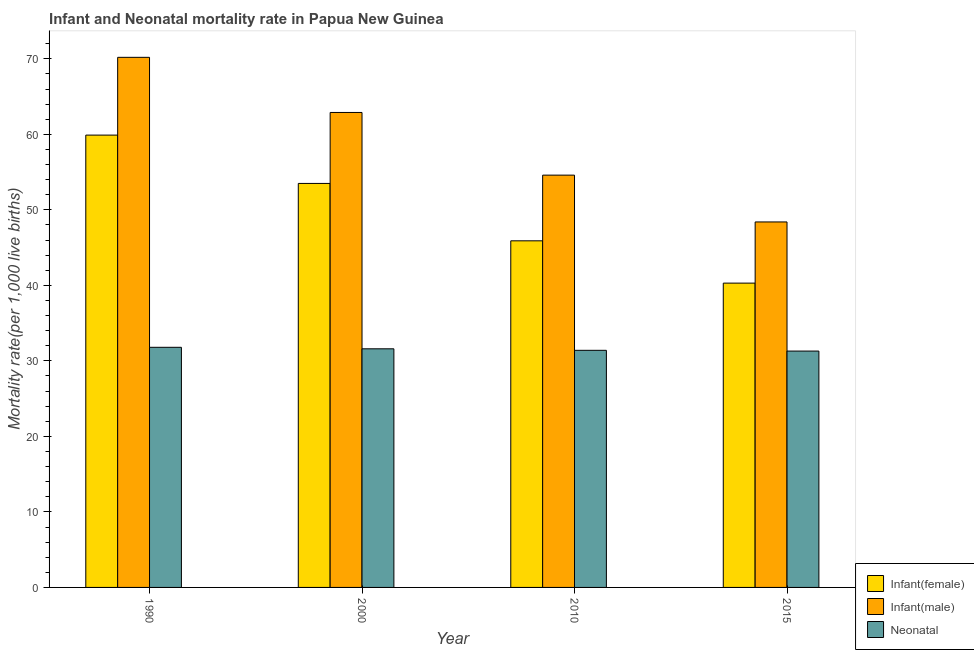How many groups of bars are there?
Your response must be concise. 4. Are the number of bars per tick equal to the number of legend labels?
Keep it short and to the point. Yes. How many bars are there on the 1st tick from the right?
Ensure brevity in your answer.  3. What is the label of the 1st group of bars from the left?
Provide a short and direct response. 1990. What is the infant mortality rate(female) in 1990?
Make the answer very short. 59.9. Across all years, what is the maximum infant mortality rate(female)?
Your response must be concise. 59.9. Across all years, what is the minimum neonatal mortality rate?
Your answer should be compact. 31.3. In which year was the neonatal mortality rate minimum?
Give a very brief answer. 2015. What is the total infant mortality rate(male) in the graph?
Give a very brief answer. 236.1. What is the difference between the infant mortality rate(male) in 2010 and that in 2015?
Your answer should be very brief. 6.2. What is the difference between the infant mortality rate(male) in 2000 and the infant mortality rate(female) in 2010?
Your answer should be compact. 8.3. What is the average neonatal mortality rate per year?
Offer a very short reply. 31.53. In how many years, is the neonatal mortality rate greater than 60?
Keep it short and to the point. 0. What is the ratio of the neonatal mortality rate in 2000 to that in 2010?
Make the answer very short. 1.01. Is the neonatal mortality rate in 2010 less than that in 2015?
Keep it short and to the point. No. What is the difference between the highest and the second highest infant mortality rate(female)?
Provide a succinct answer. 6.4. What is the difference between the highest and the lowest infant mortality rate(female)?
Give a very brief answer. 19.6. What does the 3rd bar from the left in 2010 represents?
Make the answer very short. Neonatal . What does the 3rd bar from the right in 1990 represents?
Your answer should be very brief. Infant(female). How many bars are there?
Ensure brevity in your answer.  12. Are all the bars in the graph horizontal?
Offer a terse response. No. Are the values on the major ticks of Y-axis written in scientific E-notation?
Ensure brevity in your answer.  No. Does the graph contain any zero values?
Give a very brief answer. No. Does the graph contain grids?
Your answer should be compact. No. Where does the legend appear in the graph?
Give a very brief answer. Bottom right. What is the title of the graph?
Offer a very short reply. Infant and Neonatal mortality rate in Papua New Guinea. What is the label or title of the Y-axis?
Provide a succinct answer. Mortality rate(per 1,0 live births). What is the Mortality rate(per 1,000 live births) in Infant(female) in 1990?
Offer a very short reply. 59.9. What is the Mortality rate(per 1,000 live births) of Infant(male) in 1990?
Ensure brevity in your answer.  70.2. What is the Mortality rate(per 1,000 live births) of Neonatal  in 1990?
Make the answer very short. 31.8. What is the Mortality rate(per 1,000 live births) of Infant(female) in 2000?
Ensure brevity in your answer.  53.5. What is the Mortality rate(per 1,000 live births) of Infant(male) in 2000?
Offer a very short reply. 62.9. What is the Mortality rate(per 1,000 live births) in Neonatal  in 2000?
Provide a short and direct response. 31.6. What is the Mortality rate(per 1,000 live births) in Infant(female) in 2010?
Keep it short and to the point. 45.9. What is the Mortality rate(per 1,000 live births) in Infant(male) in 2010?
Offer a terse response. 54.6. What is the Mortality rate(per 1,000 live births) of Neonatal  in 2010?
Your response must be concise. 31.4. What is the Mortality rate(per 1,000 live births) in Infant(female) in 2015?
Make the answer very short. 40.3. What is the Mortality rate(per 1,000 live births) of Infant(male) in 2015?
Make the answer very short. 48.4. What is the Mortality rate(per 1,000 live births) of Neonatal  in 2015?
Give a very brief answer. 31.3. Across all years, what is the maximum Mortality rate(per 1,000 live births) in Infant(female)?
Provide a succinct answer. 59.9. Across all years, what is the maximum Mortality rate(per 1,000 live births) of Infant(male)?
Give a very brief answer. 70.2. Across all years, what is the maximum Mortality rate(per 1,000 live births) of Neonatal ?
Provide a short and direct response. 31.8. Across all years, what is the minimum Mortality rate(per 1,000 live births) in Infant(female)?
Your answer should be compact. 40.3. Across all years, what is the minimum Mortality rate(per 1,000 live births) of Infant(male)?
Provide a succinct answer. 48.4. Across all years, what is the minimum Mortality rate(per 1,000 live births) of Neonatal ?
Give a very brief answer. 31.3. What is the total Mortality rate(per 1,000 live births) in Infant(female) in the graph?
Give a very brief answer. 199.6. What is the total Mortality rate(per 1,000 live births) of Infant(male) in the graph?
Your response must be concise. 236.1. What is the total Mortality rate(per 1,000 live births) of Neonatal  in the graph?
Make the answer very short. 126.1. What is the difference between the Mortality rate(per 1,000 live births) in Infant(male) in 1990 and that in 2000?
Give a very brief answer. 7.3. What is the difference between the Mortality rate(per 1,000 live births) in Neonatal  in 1990 and that in 2000?
Provide a short and direct response. 0.2. What is the difference between the Mortality rate(per 1,000 live births) of Infant(female) in 1990 and that in 2010?
Offer a very short reply. 14. What is the difference between the Mortality rate(per 1,000 live births) of Neonatal  in 1990 and that in 2010?
Provide a succinct answer. 0.4. What is the difference between the Mortality rate(per 1,000 live births) in Infant(female) in 1990 and that in 2015?
Provide a succinct answer. 19.6. What is the difference between the Mortality rate(per 1,000 live births) of Infant(male) in 1990 and that in 2015?
Offer a very short reply. 21.8. What is the difference between the Mortality rate(per 1,000 live births) in Neonatal  in 1990 and that in 2015?
Ensure brevity in your answer.  0.5. What is the difference between the Mortality rate(per 1,000 live births) in Infant(female) in 2000 and that in 2015?
Your answer should be compact. 13.2. What is the difference between the Mortality rate(per 1,000 live births) of Infant(female) in 2010 and that in 2015?
Offer a very short reply. 5.6. What is the difference between the Mortality rate(per 1,000 live births) of Infant(male) in 2010 and that in 2015?
Offer a terse response. 6.2. What is the difference between the Mortality rate(per 1,000 live births) of Infant(female) in 1990 and the Mortality rate(per 1,000 live births) of Infant(male) in 2000?
Offer a very short reply. -3. What is the difference between the Mortality rate(per 1,000 live births) in Infant(female) in 1990 and the Mortality rate(per 1,000 live births) in Neonatal  in 2000?
Provide a short and direct response. 28.3. What is the difference between the Mortality rate(per 1,000 live births) in Infant(male) in 1990 and the Mortality rate(per 1,000 live births) in Neonatal  in 2000?
Provide a short and direct response. 38.6. What is the difference between the Mortality rate(per 1,000 live births) of Infant(female) in 1990 and the Mortality rate(per 1,000 live births) of Infant(male) in 2010?
Your answer should be compact. 5.3. What is the difference between the Mortality rate(per 1,000 live births) in Infant(male) in 1990 and the Mortality rate(per 1,000 live births) in Neonatal  in 2010?
Your response must be concise. 38.8. What is the difference between the Mortality rate(per 1,000 live births) in Infant(female) in 1990 and the Mortality rate(per 1,000 live births) in Infant(male) in 2015?
Give a very brief answer. 11.5. What is the difference between the Mortality rate(per 1,000 live births) in Infant(female) in 1990 and the Mortality rate(per 1,000 live births) in Neonatal  in 2015?
Provide a short and direct response. 28.6. What is the difference between the Mortality rate(per 1,000 live births) of Infant(male) in 1990 and the Mortality rate(per 1,000 live births) of Neonatal  in 2015?
Provide a succinct answer. 38.9. What is the difference between the Mortality rate(per 1,000 live births) of Infant(female) in 2000 and the Mortality rate(per 1,000 live births) of Neonatal  in 2010?
Your answer should be compact. 22.1. What is the difference between the Mortality rate(per 1,000 live births) in Infant(male) in 2000 and the Mortality rate(per 1,000 live births) in Neonatal  in 2010?
Your response must be concise. 31.5. What is the difference between the Mortality rate(per 1,000 live births) in Infant(female) in 2000 and the Mortality rate(per 1,000 live births) in Infant(male) in 2015?
Provide a short and direct response. 5.1. What is the difference between the Mortality rate(per 1,000 live births) in Infant(male) in 2000 and the Mortality rate(per 1,000 live births) in Neonatal  in 2015?
Provide a short and direct response. 31.6. What is the difference between the Mortality rate(per 1,000 live births) in Infant(female) in 2010 and the Mortality rate(per 1,000 live births) in Neonatal  in 2015?
Offer a terse response. 14.6. What is the difference between the Mortality rate(per 1,000 live births) in Infant(male) in 2010 and the Mortality rate(per 1,000 live births) in Neonatal  in 2015?
Your answer should be compact. 23.3. What is the average Mortality rate(per 1,000 live births) of Infant(female) per year?
Provide a short and direct response. 49.9. What is the average Mortality rate(per 1,000 live births) of Infant(male) per year?
Provide a succinct answer. 59.02. What is the average Mortality rate(per 1,000 live births) in Neonatal  per year?
Ensure brevity in your answer.  31.52. In the year 1990, what is the difference between the Mortality rate(per 1,000 live births) in Infant(female) and Mortality rate(per 1,000 live births) in Neonatal ?
Your answer should be very brief. 28.1. In the year 1990, what is the difference between the Mortality rate(per 1,000 live births) in Infant(male) and Mortality rate(per 1,000 live births) in Neonatal ?
Offer a terse response. 38.4. In the year 2000, what is the difference between the Mortality rate(per 1,000 live births) in Infant(female) and Mortality rate(per 1,000 live births) in Infant(male)?
Make the answer very short. -9.4. In the year 2000, what is the difference between the Mortality rate(per 1,000 live births) of Infant(female) and Mortality rate(per 1,000 live births) of Neonatal ?
Your answer should be very brief. 21.9. In the year 2000, what is the difference between the Mortality rate(per 1,000 live births) of Infant(male) and Mortality rate(per 1,000 live births) of Neonatal ?
Ensure brevity in your answer.  31.3. In the year 2010, what is the difference between the Mortality rate(per 1,000 live births) of Infant(male) and Mortality rate(per 1,000 live births) of Neonatal ?
Provide a succinct answer. 23.2. In the year 2015, what is the difference between the Mortality rate(per 1,000 live births) of Infant(female) and Mortality rate(per 1,000 live births) of Infant(male)?
Give a very brief answer. -8.1. In the year 2015, what is the difference between the Mortality rate(per 1,000 live births) in Infant(male) and Mortality rate(per 1,000 live births) in Neonatal ?
Ensure brevity in your answer.  17.1. What is the ratio of the Mortality rate(per 1,000 live births) of Infant(female) in 1990 to that in 2000?
Your response must be concise. 1.12. What is the ratio of the Mortality rate(per 1,000 live births) of Infant(male) in 1990 to that in 2000?
Your answer should be compact. 1.12. What is the ratio of the Mortality rate(per 1,000 live births) in Infant(female) in 1990 to that in 2010?
Offer a terse response. 1.3. What is the ratio of the Mortality rate(per 1,000 live births) of Neonatal  in 1990 to that in 2010?
Your answer should be very brief. 1.01. What is the ratio of the Mortality rate(per 1,000 live births) of Infant(female) in 1990 to that in 2015?
Your answer should be compact. 1.49. What is the ratio of the Mortality rate(per 1,000 live births) of Infant(male) in 1990 to that in 2015?
Your answer should be very brief. 1.45. What is the ratio of the Mortality rate(per 1,000 live births) of Neonatal  in 1990 to that in 2015?
Your answer should be compact. 1.02. What is the ratio of the Mortality rate(per 1,000 live births) of Infant(female) in 2000 to that in 2010?
Give a very brief answer. 1.17. What is the ratio of the Mortality rate(per 1,000 live births) of Infant(male) in 2000 to that in 2010?
Your answer should be very brief. 1.15. What is the ratio of the Mortality rate(per 1,000 live births) of Neonatal  in 2000 to that in 2010?
Give a very brief answer. 1.01. What is the ratio of the Mortality rate(per 1,000 live births) of Infant(female) in 2000 to that in 2015?
Keep it short and to the point. 1.33. What is the ratio of the Mortality rate(per 1,000 live births) of Infant(male) in 2000 to that in 2015?
Provide a succinct answer. 1.3. What is the ratio of the Mortality rate(per 1,000 live births) of Neonatal  in 2000 to that in 2015?
Offer a very short reply. 1.01. What is the ratio of the Mortality rate(per 1,000 live births) of Infant(female) in 2010 to that in 2015?
Keep it short and to the point. 1.14. What is the ratio of the Mortality rate(per 1,000 live births) in Infant(male) in 2010 to that in 2015?
Give a very brief answer. 1.13. What is the difference between the highest and the second highest Mortality rate(per 1,000 live births) in Infant(male)?
Your answer should be compact. 7.3. What is the difference between the highest and the lowest Mortality rate(per 1,000 live births) in Infant(female)?
Offer a very short reply. 19.6. What is the difference between the highest and the lowest Mortality rate(per 1,000 live births) of Infant(male)?
Offer a very short reply. 21.8. 